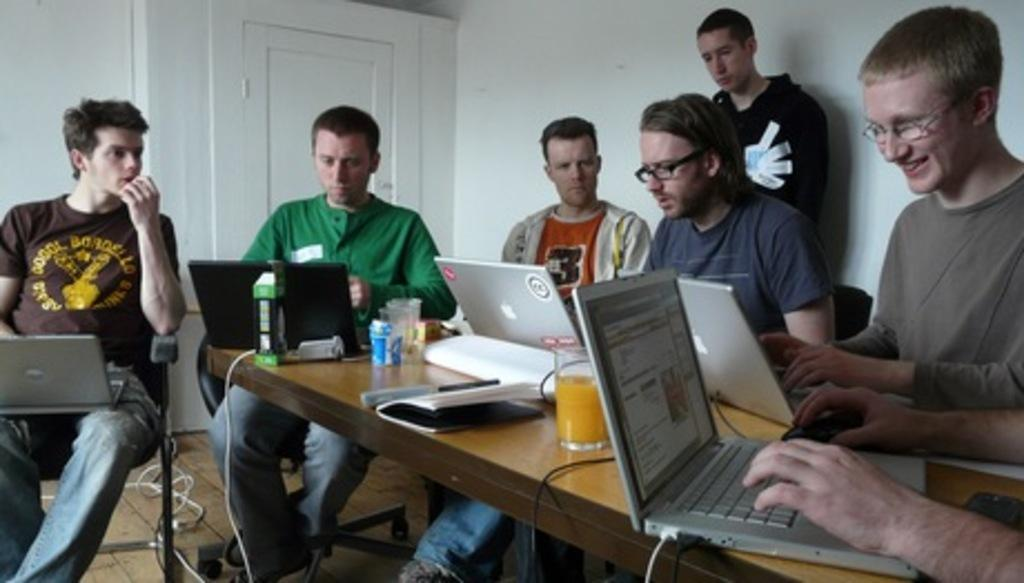What are the people in the image doing? The people in the image are sitting on chairs. What objects can be seen on the table in the image? There are laptops on a table in the image. What type of beverage is being consumed in the image? There are juice glasses in the image. What type of cork can be seen in the image? There is no cork present in the image. Can you describe the mist in the image? There is no mist present in the image. 